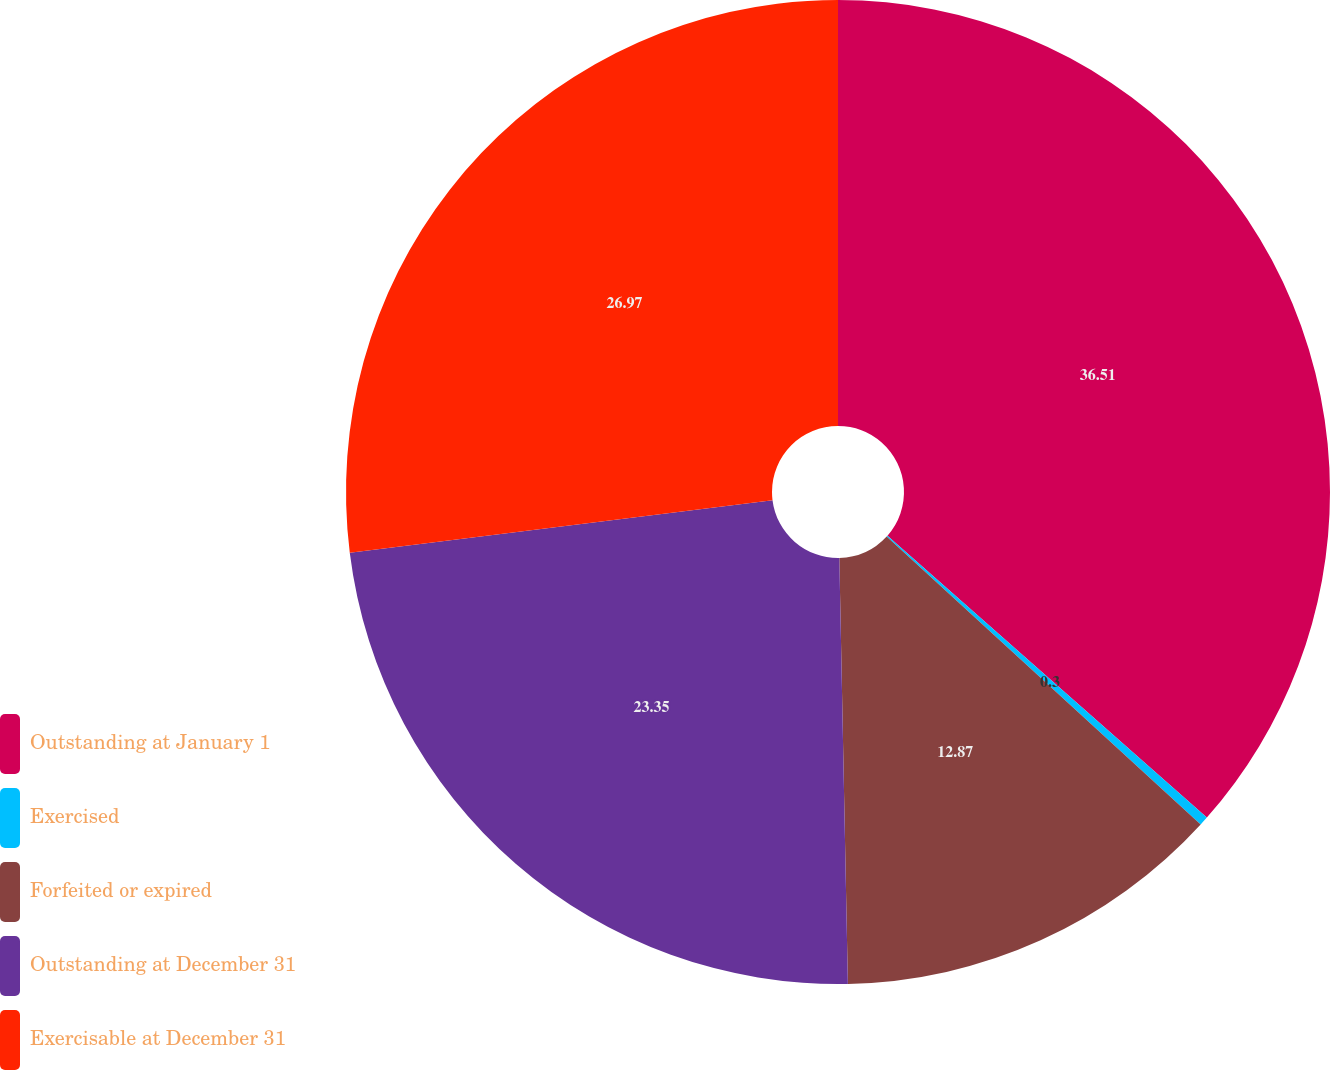<chart> <loc_0><loc_0><loc_500><loc_500><pie_chart><fcel>Outstanding at January 1<fcel>Exercised<fcel>Forfeited or expired<fcel>Outstanding at December 31<fcel>Exercisable at December 31<nl><fcel>36.51%<fcel>0.3%<fcel>12.87%<fcel>23.35%<fcel>26.97%<nl></chart> 